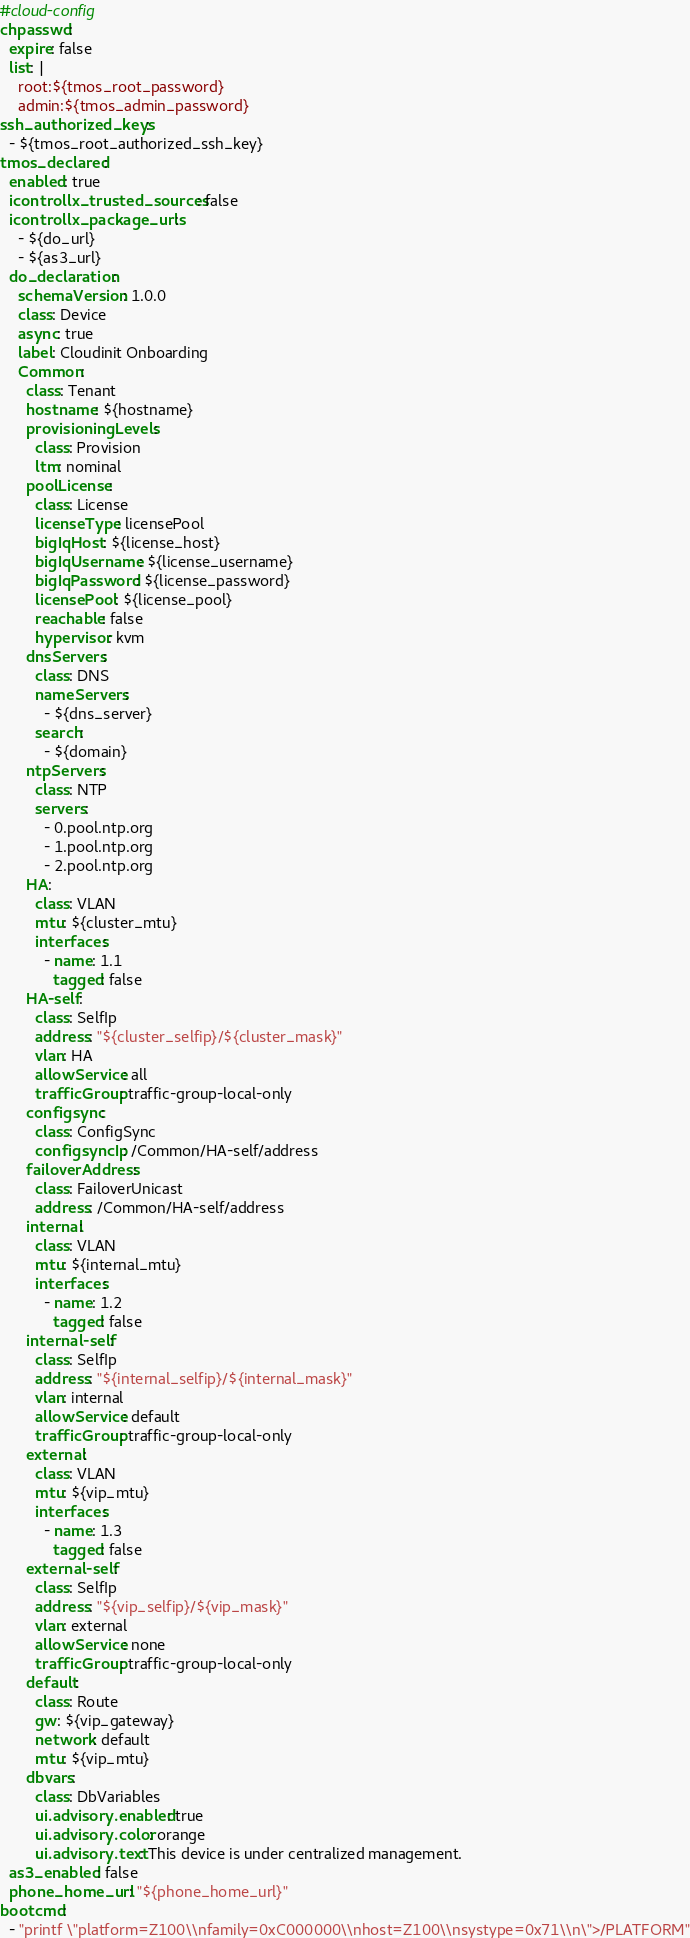<code> <loc_0><loc_0><loc_500><loc_500><_YAML_>#cloud-config
chpasswd:
  expire: false
  list: |
    root:${tmos_root_password}
    admin:${tmos_admin_password}
ssh_authorized_keys:
  - ${tmos_root_authorized_ssh_key}
tmos_declared:
  enabled: true
  icontrollx_trusted_sources: false
  icontrollx_package_urls:
    - ${do_url}
    - ${as3_url}
  do_declaration:
    schemaVersion: 1.0.0
    class: Device
    async: true
    label: Cloudinit Onboarding
    Common:
      class: Tenant
      hostname: ${hostname}
      provisioningLevels:
        class: Provision
        ltm: nominal
      poolLicense:
        class: License
        licenseType: licensePool
        bigIqHost: ${license_host}
        bigIqUsername: ${license_username}
        bigIqPassword: ${license_password}
        licensePool: ${license_pool}
        reachable: false
        hypervisor: kvm
      dnsServers:
        class: DNS
        nameServers:
          - ${dns_server}
        search:
          - ${domain}
      ntpServers:
        class: NTP
        servers:
          - 0.pool.ntp.org
          - 1.pool.ntp.org
          - 2.pool.ntp.org
      HA:
        class: VLAN
        mtu: ${cluster_mtu}
        interfaces:
          - name: 1.1
            tagged: false
      HA-self:
        class: SelfIp
        address: "${cluster_selfip}/${cluster_mask}"
        vlan: HA
        allowService: all
        trafficGroup: traffic-group-local-only
      configsync:
        class: ConfigSync
        configsyncIp: /Common/HA-self/address
      failoverAddress:
        class: FailoverUnicast
        address: /Common/HA-self/address
      internal:
        class: VLAN
        mtu: ${internal_mtu}
        interfaces:
          - name: 1.2
            tagged: false
      internal-self:
        class: SelfIp
        address: "${internal_selfip}/${internal_mask}"
        vlan: internal
        allowService: default
        trafficGroup: traffic-group-local-only
      external:
        class: VLAN
        mtu: ${vip_mtu}
        interfaces:
          - name: 1.3
            tagged: false
      external-self:
        class: SelfIp
        address: "${vip_selfip}/${vip_mask}"
        vlan: external
        allowService: none
        trafficGroup: traffic-group-local-only
      default:
        class: Route
        gw: ${vip_gateway}
        network: default
        mtu: ${vip_mtu}
      dbvars:
        class: DbVariables
        ui.advisory.enabled: true
        ui.advisory.color: orange
        ui.advisory.text: This device is under centralized management.
  as3_enabled: false
  phone_home_url: "${phone_home_url}"
bootcmd:
  - "printf \"platform=Z100\\nfamily=0xC000000\\nhost=Z100\\nsystype=0x71\\n\">/PLATFORM"</code> 